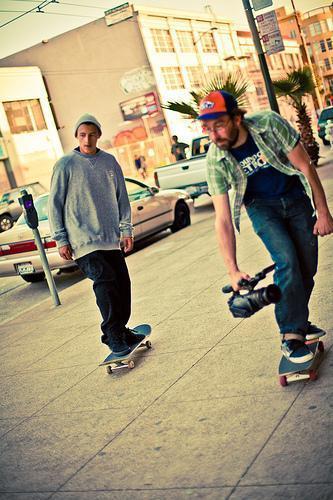How many skateboarders are there?
Give a very brief answer. 2. How many people are wearing grey shirts?
Give a very brief answer. 1. 